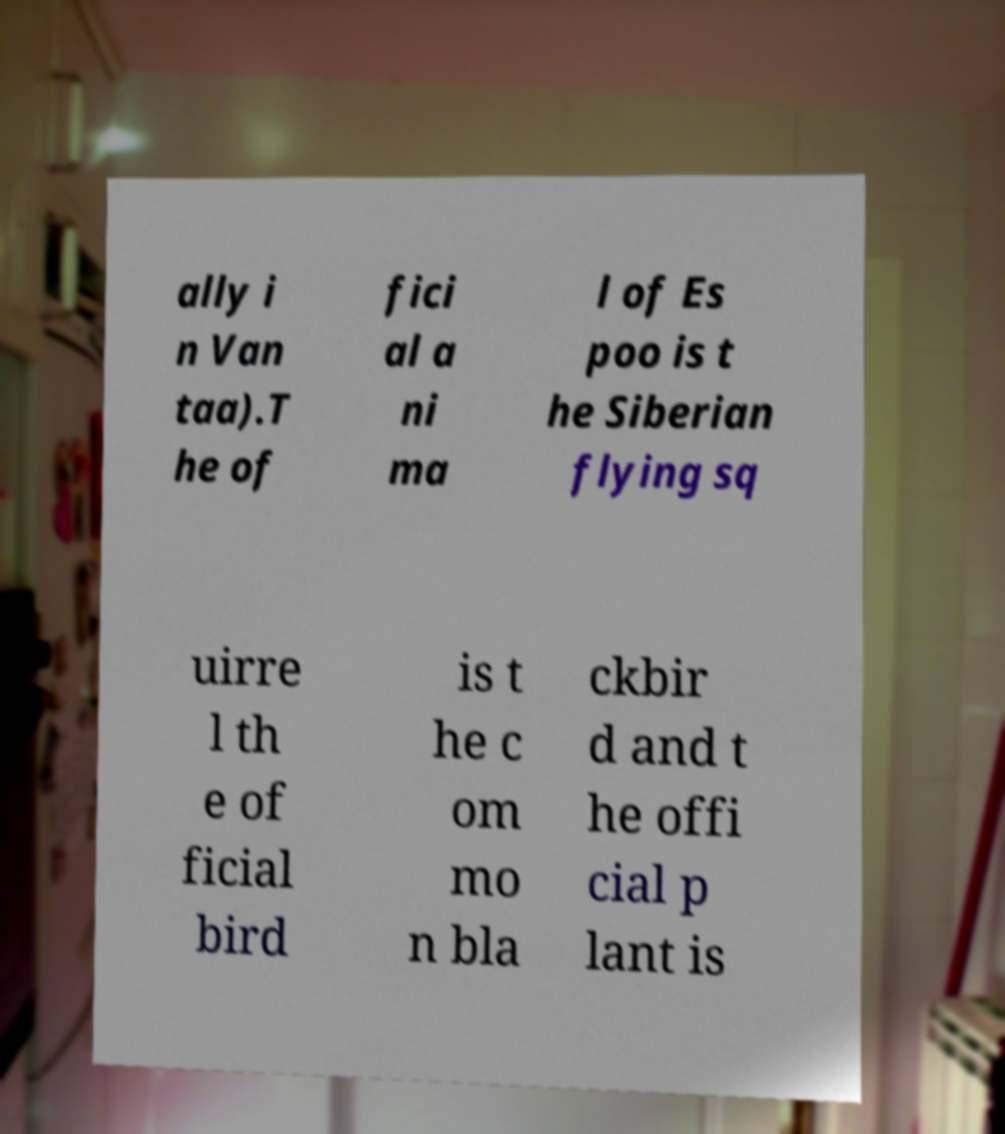There's text embedded in this image that I need extracted. Can you transcribe it verbatim? ally i n Van taa).T he of fici al a ni ma l of Es poo is t he Siberian flying sq uirre l th e of ficial bird is t he c om mo n bla ckbir d and t he offi cial p lant is 